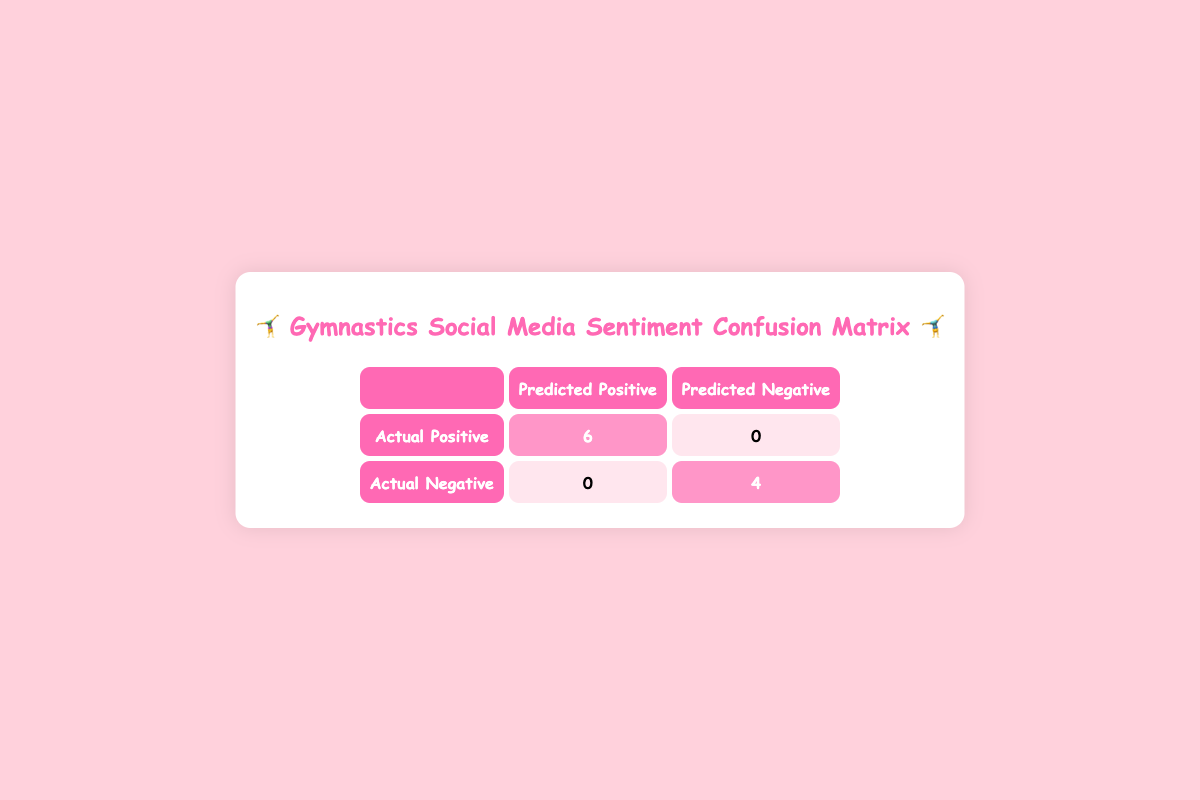What is the number of actual positive comments that were predicted as positive? In the "Actual Positive" row under "Predicted Positive," the value is highlighted as 6. This indicates the number of actual positive comments that were correctly identified as positive.
Answer: 6 What is the total number of actual negative comments? In the "Actual Negative" row, the highlighted number under "Predicted Negative" is 4, which represents the total number of actual negative comments.
Answer: 4 How many comments were misclassified as negative? To find this, we look at the "Actual Positive" row under "Predicted Negative," which contains 0. This means there were no positive comments incorrectly labeled as negative.
Answer: 0 Is it true that all predicted negative comments were correctly classified? Yes, looking under the "Actual Negative" row and the "Predicted Negative" column, the value is highlighted as 4. This shows that all negative comments were accurately predicted, making the statement true.
Answer: Yes What percentage of actual positive comments were correctly predicted? There were 6 actual positive comments, all of which were predicted as positive. To find the percentage, we calculate (6/6) * 100%, which equals 100%.
Answer: 100% What is the difference between the predicted positive and predicted negative comments? The predicted positive comments total 6 and the predicted negative comments total 0. The difference is 6 - 0 = 6.
Answer: 6 Can you say that the model has achieved perfect accuracy for positive comments? Yes, since all 6 actual positive comments were correctly identified as positive, indicating perfect accuracy for this category.
Answer: Yes How many total comments are accounted for in the matrix? The total comments can be computed by adding the number of actual positives and actual negatives: 6 (Actual Positive) + 4 (Actual Negative) = 10 total comments.
Answer: 10 What is the overall accuracy of the sentiment classification? To calculate overall accuracy, add the true positives (6) and true negatives (4), which equals 10 correct predictions out of 10 total comments, yielding an accuracy of 100%.
Answer: 100% 